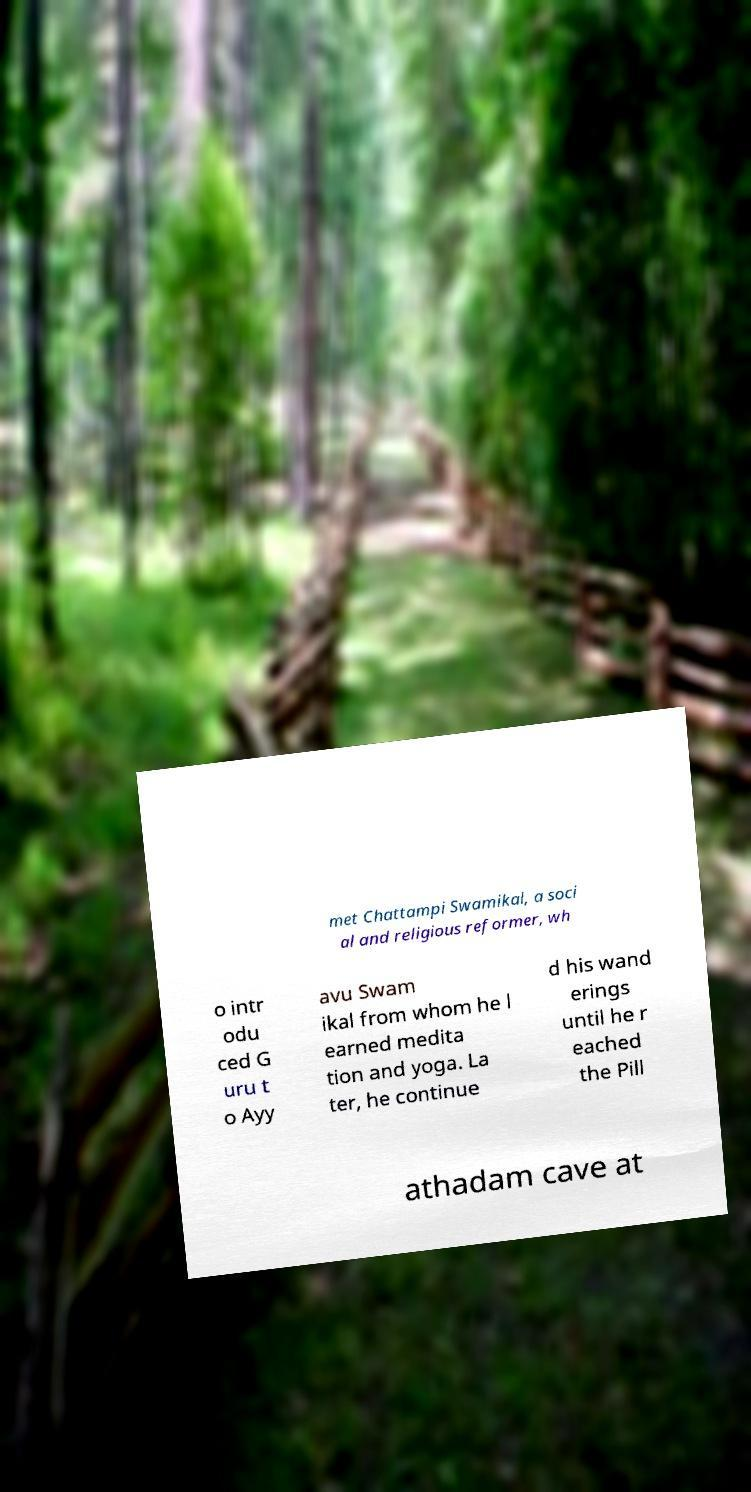I need the written content from this picture converted into text. Can you do that? met Chattampi Swamikal, a soci al and religious reformer, wh o intr odu ced G uru t o Ayy avu Swam ikal from whom he l earned medita tion and yoga. La ter, he continue d his wand erings until he r eached the Pill athadam cave at 